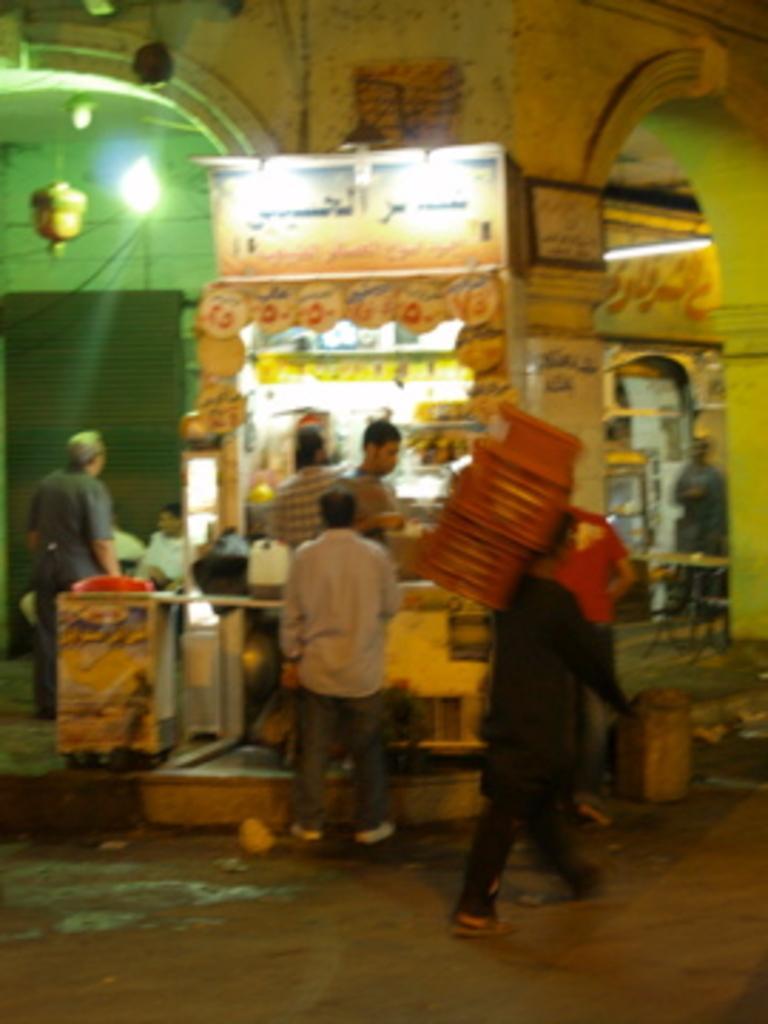Please provide a concise description of this image. In this image we can see people, stalls, lights, boards, pillars, wall, shutter, and few objects. At the bottom of the image we can see road. 